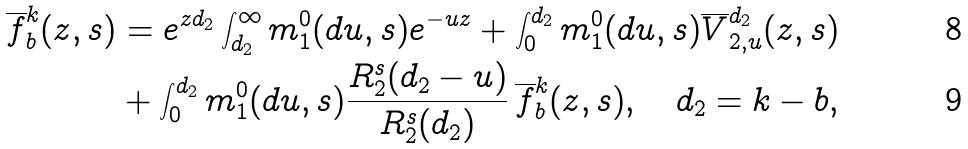<formula> <loc_0><loc_0><loc_500><loc_500>\overline { f } _ { b } ^ { k } ( z , s ) & = e ^ { z d _ { 2 } } \int _ { d _ { 2 } } ^ { \infty } m _ { 1 } ^ { 0 } ( d u , s ) e ^ { - u z } + \int _ { 0 } ^ { d _ { 2 } } m _ { 1 } ^ { 0 } ( d u , s ) \overline { V } _ { 2 , u } ^ { d _ { 2 } } ( z , s ) \\ & + \int _ { 0 } ^ { d _ { 2 } } m _ { 1 } ^ { 0 } ( d u , s ) \frac { R _ { 2 } ^ { s } ( d _ { 2 } - u ) } { R _ { 2 } ^ { s } ( d _ { 2 } ) } \, \overline { f } _ { b } ^ { k } ( z , s ) , \quad d _ { 2 } = k - b ,</formula> 